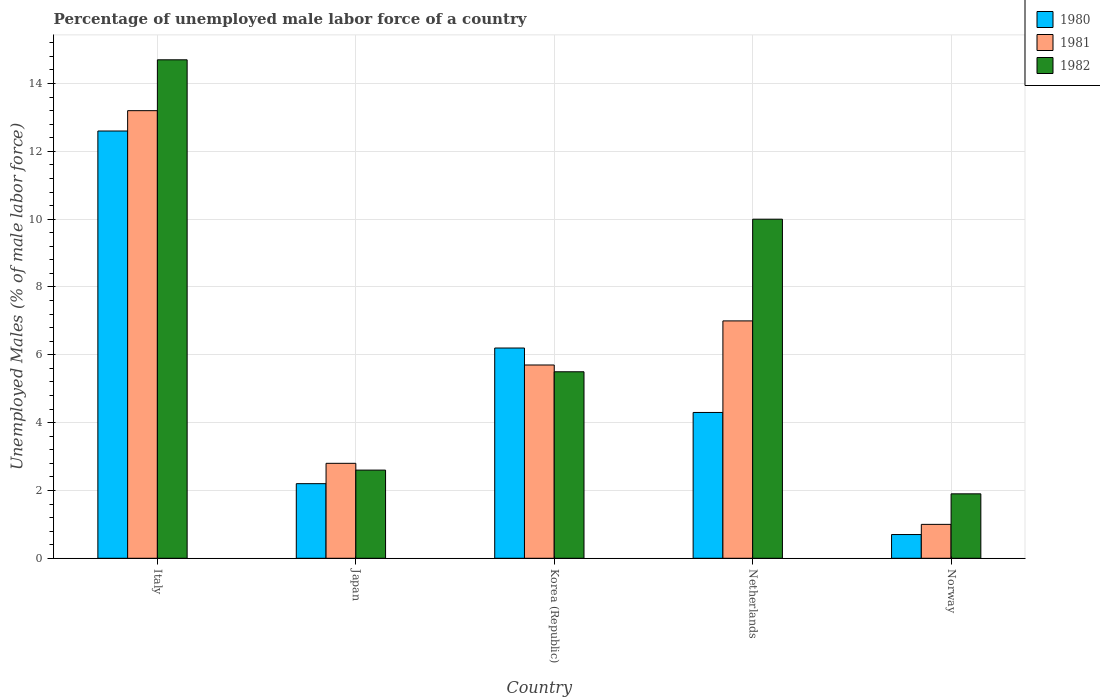How many different coloured bars are there?
Keep it short and to the point. 3. Are the number of bars per tick equal to the number of legend labels?
Provide a succinct answer. Yes. Are the number of bars on each tick of the X-axis equal?
Provide a succinct answer. Yes. How many bars are there on the 1st tick from the right?
Provide a short and direct response. 3. In how many cases, is the number of bars for a given country not equal to the number of legend labels?
Your answer should be very brief. 0. What is the percentage of unemployed male labor force in 1980 in Italy?
Provide a short and direct response. 12.6. Across all countries, what is the maximum percentage of unemployed male labor force in 1981?
Your answer should be compact. 13.2. Across all countries, what is the minimum percentage of unemployed male labor force in 1980?
Make the answer very short. 0.7. In which country was the percentage of unemployed male labor force in 1981 minimum?
Keep it short and to the point. Norway. What is the total percentage of unemployed male labor force in 1981 in the graph?
Your response must be concise. 29.7. What is the difference between the percentage of unemployed male labor force in 1981 in Italy and that in Japan?
Offer a terse response. 10.4. What is the difference between the percentage of unemployed male labor force in 1982 in Netherlands and the percentage of unemployed male labor force in 1981 in Korea (Republic)?
Give a very brief answer. 4.3. What is the average percentage of unemployed male labor force in 1980 per country?
Offer a very short reply. 5.2. What is the difference between the percentage of unemployed male labor force of/in 1982 and percentage of unemployed male labor force of/in 1980 in Korea (Republic)?
Make the answer very short. -0.7. In how many countries, is the percentage of unemployed male labor force in 1981 greater than 9.6 %?
Your response must be concise. 1. What is the ratio of the percentage of unemployed male labor force in 1981 in Japan to that in Norway?
Give a very brief answer. 2.8. Is the percentage of unemployed male labor force in 1980 in Korea (Republic) less than that in Norway?
Offer a very short reply. No. Is the difference between the percentage of unemployed male labor force in 1982 in Korea (Republic) and Netherlands greater than the difference between the percentage of unemployed male labor force in 1980 in Korea (Republic) and Netherlands?
Your answer should be compact. No. What is the difference between the highest and the lowest percentage of unemployed male labor force in 1980?
Give a very brief answer. 11.9. Is the sum of the percentage of unemployed male labor force in 1982 in Korea (Republic) and Norway greater than the maximum percentage of unemployed male labor force in 1980 across all countries?
Your response must be concise. No. What does the 2nd bar from the right in Japan represents?
Your answer should be compact. 1981. Are all the bars in the graph horizontal?
Your answer should be very brief. No. How many countries are there in the graph?
Your answer should be very brief. 5. Are the values on the major ticks of Y-axis written in scientific E-notation?
Keep it short and to the point. No. Does the graph contain any zero values?
Offer a very short reply. No. Does the graph contain grids?
Your answer should be compact. Yes. How are the legend labels stacked?
Your response must be concise. Vertical. What is the title of the graph?
Give a very brief answer. Percentage of unemployed male labor force of a country. What is the label or title of the X-axis?
Your response must be concise. Country. What is the label or title of the Y-axis?
Your answer should be compact. Unemployed Males (% of male labor force). What is the Unemployed Males (% of male labor force) of 1980 in Italy?
Provide a succinct answer. 12.6. What is the Unemployed Males (% of male labor force) of 1981 in Italy?
Your answer should be compact. 13.2. What is the Unemployed Males (% of male labor force) of 1982 in Italy?
Provide a short and direct response. 14.7. What is the Unemployed Males (% of male labor force) of 1980 in Japan?
Offer a terse response. 2.2. What is the Unemployed Males (% of male labor force) in 1981 in Japan?
Your response must be concise. 2.8. What is the Unemployed Males (% of male labor force) of 1982 in Japan?
Provide a short and direct response. 2.6. What is the Unemployed Males (% of male labor force) in 1980 in Korea (Republic)?
Offer a very short reply. 6.2. What is the Unemployed Males (% of male labor force) of 1981 in Korea (Republic)?
Offer a terse response. 5.7. What is the Unemployed Males (% of male labor force) of 1980 in Netherlands?
Keep it short and to the point. 4.3. What is the Unemployed Males (% of male labor force) of 1982 in Netherlands?
Give a very brief answer. 10. What is the Unemployed Males (% of male labor force) in 1980 in Norway?
Make the answer very short. 0.7. What is the Unemployed Males (% of male labor force) of 1981 in Norway?
Make the answer very short. 1. What is the Unemployed Males (% of male labor force) in 1982 in Norway?
Offer a very short reply. 1.9. Across all countries, what is the maximum Unemployed Males (% of male labor force) in 1980?
Offer a very short reply. 12.6. Across all countries, what is the maximum Unemployed Males (% of male labor force) in 1981?
Offer a terse response. 13.2. Across all countries, what is the maximum Unemployed Males (% of male labor force) of 1982?
Provide a short and direct response. 14.7. Across all countries, what is the minimum Unemployed Males (% of male labor force) of 1980?
Make the answer very short. 0.7. Across all countries, what is the minimum Unemployed Males (% of male labor force) of 1982?
Your answer should be compact. 1.9. What is the total Unemployed Males (% of male labor force) of 1980 in the graph?
Offer a terse response. 26. What is the total Unemployed Males (% of male labor force) in 1981 in the graph?
Make the answer very short. 29.7. What is the total Unemployed Males (% of male labor force) of 1982 in the graph?
Your answer should be very brief. 34.7. What is the difference between the Unemployed Males (% of male labor force) of 1981 in Italy and that in Japan?
Offer a terse response. 10.4. What is the difference between the Unemployed Males (% of male labor force) of 1981 in Italy and that in Korea (Republic)?
Provide a succinct answer. 7.5. What is the difference between the Unemployed Males (% of male labor force) of 1980 in Italy and that in Netherlands?
Provide a short and direct response. 8.3. What is the difference between the Unemployed Males (% of male labor force) of 1982 in Italy and that in Netherlands?
Keep it short and to the point. 4.7. What is the difference between the Unemployed Males (% of male labor force) of 1980 in Italy and that in Norway?
Your answer should be very brief. 11.9. What is the difference between the Unemployed Males (% of male labor force) in 1982 in Italy and that in Norway?
Provide a succinct answer. 12.8. What is the difference between the Unemployed Males (% of male labor force) of 1980 in Japan and that in Korea (Republic)?
Your response must be concise. -4. What is the difference between the Unemployed Males (% of male labor force) in 1981 in Japan and that in Korea (Republic)?
Make the answer very short. -2.9. What is the difference between the Unemployed Males (% of male labor force) of 1982 in Japan and that in Korea (Republic)?
Ensure brevity in your answer.  -2.9. What is the difference between the Unemployed Males (% of male labor force) of 1980 in Japan and that in Netherlands?
Your answer should be compact. -2.1. What is the difference between the Unemployed Males (% of male labor force) in 1980 in Japan and that in Norway?
Your answer should be very brief. 1.5. What is the difference between the Unemployed Males (% of male labor force) in 1982 in Japan and that in Norway?
Your answer should be compact. 0.7. What is the difference between the Unemployed Males (% of male labor force) of 1980 in Korea (Republic) and that in Netherlands?
Your answer should be very brief. 1.9. What is the difference between the Unemployed Males (% of male labor force) in 1981 in Korea (Republic) and that in Netherlands?
Keep it short and to the point. -1.3. What is the difference between the Unemployed Males (% of male labor force) in 1982 in Korea (Republic) and that in Netherlands?
Your answer should be very brief. -4.5. What is the difference between the Unemployed Males (% of male labor force) of 1982 in Korea (Republic) and that in Norway?
Give a very brief answer. 3.6. What is the difference between the Unemployed Males (% of male labor force) in 1980 in Netherlands and that in Norway?
Ensure brevity in your answer.  3.6. What is the difference between the Unemployed Males (% of male labor force) in 1981 in Netherlands and that in Norway?
Make the answer very short. 6. What is the difference between the Unemployed Males (% of male labor force) of 1980 in Italy and the Unemployed Males (% of male labor force) of 1982 in Japan?
Your answer should be compact. 10. What is the difference between the Unemployed Males (% of male labor force) in 1980 in Italy and the Unemployed Males (% of male labor force) in 1981 in Korea (Republic)?
Your answer should be compact. 6.9. What is the difference between the Unemployed Males (% of male labor force) in 1980 in Italy and the Unemployed Males (% of male labor force) in 1982 in Korea (Republic)?
Give a very brief answer. 7.1. What is the difference between the Unemployed Males (% of male labor force) in 1981 in Italy and the Unemployed Males (% of male labor force) in 1982 in Korea (Republic)?
Ensure brevity in your answer.  7.7. What is the difference between the Unemployed Males (% of male labor force) in 1980 in Italy and the Unemployed Males (% of male labor force) in 1981 in Netherlands?
Offer a terse response. 5.6. What is the difference between the Unemployed Males (% of male labor force) of 1981 in Italy and the Unemployed Males (% of male labor force) of 1982 in Norway?
Make the answer very short. 11.3. What is the difference between the Unemployed Males (% of male labor force) in 1980 in Japan and the Unemployed Males (% of male labor force) in 1981 in Korea (Republic)?
Make the answer very short. -3.5. What is the difference between the Unemployed Males (% of male labor force) in 1980 in Japan and the Unemployed Males (% of male labor force) in 1982 in Korea (Republic)?
Your answer should be compact. -3.3. What is the difference between the Unemployed Males (% of male labor force) of 1981 in Japan and the Unemployed Males (% of male labor force) of 1982 in Korea (Republic)?
Offer a very short reply. -2.7. What is the difference between the Unemployed Males (% of male labor force) in 1980 in Japan and the Unemployed Males (% of male labor force) in 1981 in Norway?
Ensure brevity in your answer.  1.2. What is the difference between the Unemployed Males (% of male labor force) in 1980 in Korea (Republic) and the Unemployed Males (% of male labor force) in 1981 in Netherlands?
Give a very brief answer. -0.8. What is the difference between the Unemployed Males (% of male labor force) of 1980 in Korea (Republic) and the Unemployed Males (% of male labor force) of 1982 in Netherlands?
Your response must be concise. -3.8. What is the difference between the Unemployed Males (% of male labor force) of 1980 in Korea (Republic) and the Unemployed Males (% of male labor force) of 1981 in Norway?
Keep it short and to the point. 5.2. What is the difference between the Unemployed Males (% of male labor force) of 1981 in Korea (Republic) and the Unemployed Males (% of male labor force) of 1982 in Norway?
Offer a terse response. 3.8. What is the difference between the Unemployed Males (% of male labor force) of 1980 in Netherlands and the Unemployed Males (% of male labor force) of 1982 in Norway?
Provide a short and direct response. 2.4. What is the difference between the Unemployed Males (% of male labor force) of 1981 in Netherlands and the Unemployed Males (% of male labor force) of 1982 in Norway?
Ensure brevity in your answer.  5.1. What is the average Unemployed Males (% of male labor force) of 1981 per country?
Provide a short and direct response. 5.94. What is the average Unemployed Males (% of male labor force) in 1982 per country?
Keep it short and to the point. 6.94. What is the difference between the Unemployed Males (% of male labor force) in 1980 and Unemployed Males (% of male labor force) in 1981 in Japan?
Offer a very short reply. -0.6. What is the difference between the Unemployed Males (% of male labor force) in 1980 and Unemployed Males (% of male labor force) in 1982 in Japan?
Make the answer very short. -0.4. What is the difference between the Unemployed Males (% of male labor force) of 1980 and Unemployed Males (% of male labor force) of 1981 in Korea (Republic)?
Your answer should be very brief. 0.5. What is the difference between the Unemployed Males (% of male labor force) in 1980 and Unemployed Males (% of male labor force) in 1982 in Korea (Republic)?
Offer a very short reply. 0.7. What is the difference between the Unemployed Males (% of male labor force) of 1980 and Unemployed Males (% of male labor force) of 1981 in Netherlands?
Your response must be concise. -2.7. What is the difference between the Unemployed Males (% of male labor force) in 1980 and Unemployed Males (% of male labor force) in 1982 in Netherlands?
Keep it short and to the point. -5.7. What is the difference between the Unemployed Males (% of male labor force) of 1981 and Unemployed Males (% of male labor force) of 1982 in Netherlands?
Offer a very short reply. -3. What is the difference between the Unemployed Males (% of male labor force) of 1980 and Unemployed Males (% of male labor force) of 1981 in Norway?
Make the answer very short. -0.3. What is the ratio of the Unemployed Males (% of male labor force) of 1980 in Italy to that in Japan?
Offer a terse response. 5.73. What is the ratio of the Unemployed Males (% of male labor force) of 1981 in Italy to that in Japan?
Provide a succinct answer. 4.71. What is the ratio of the Unemployed Males (% of male labor force) in 1982 in Italy to that in Japan?
Make the answer very short. 5.65. What is the ratio of the Unemployed Males (% of male labor force) in 1980 in Italy to that in Korea (Republic)?
Offer a very short reply. 2.03. What is the ratio of the Unemployed Males (% of male labor force) of 1981 in Italy to that in Korea (Republic)?
Ensure brevity in your answer.  2.32. What is the ratio of the Unemployed Males (% of male labor force) in 1982 in Italy to that in Korea (Republic)?
Your answer should be very brief. 2.67. What is the ratio of the Unemployed Males (% of male labor force) in 1980 in Italy to that in Netherlands?
Your answer should be very brief. 2.93. What is the ratio of the Unemployed Males (% of male labor force) of 1981 in Italy to that in Netherlands?
Offer a terse response. 1.89. What is the ratio of the Unemployed Males (% of male labor force) in 1982 in Italy to that in Netherlands?
Make the answer very short. 1.47. What is the ratio of the Unemployed Males (% of male labor force) in 1982 in Italy to that in Norway?
Give a very brief answer. 7.74. What is the ratio of the Unemployed Males (% of male labor force) in 1980 in Japan to that in Korea (Republic)?
Your answer should be very brief. 0.35. What is the ratio of the Unemployed Males (% of male labor force) in 1981 in Japan to that in Korea (Republic)?
Provide a short and direct response. 0.49. What is the ratio of the Unemployed Males (% of male labor force) of 1982 in Japan to that in Korea (Republic)?
Your answer should be very brief. 0.47. What is the ratio of the Unemployed Males (% of male labor force) of 1980 in Japan to that in Netherlands?
Provide a short and direct response. 0.51. What is the ratio of the Unemployed Males (% of male labor force) in 1981 in Japan to that in Netherlands?
Your answer should be very brief. 0.4. What is the ratio of the Unemployed Males (% of male labor force) of 1982 in Japan to that in Netherlands?
Your answer should be very brief. 0.26. What is the ratio of the Unemployed Males (% of male labor force) of 1980 in Japan to that in Norway?
Offer a terse response. 3.14. What is the ratio of the Unemployed Males (% of male labor force) in 1981 in Japan to that in Norway?
Your response must be concise. 2.8. What is the ratio of the Unemployed Males (% of male labor force) in 1982 in Japan to that in Norway?
Give a very brief answer. 1.37. What is the ratio of the Unemployed Males (% of male labor force) of 1980 in Korea (Republic) to that in Netherlands?
Keep it short and to the point. 1.44. What is the ratio of the Unemployed Males (% of male labor force) of 1981 in Korea (Republic) to that in Netherlands?
Offer a terse response. 0.81. What is the ratio of the Unemployed Males (% of male labor force) of 1982 in Korea (Republic) to that in Netherlands?
Ensure brevity in your answer.  0.55. What is the ratio of the Unemployed Males (% of male labor force) of 1980 in Korea (Republic) to that in Norway?
Make the answer very short. 8.86. What is the ratio of the Unemployed Males (% of male labor force) in 1982 in Korea (Republic) to that in Norway?
Give a very brief answer. 2.89. What is the ratio of the Unemployed Males (% of male labor force) in 1980 in Netherlands to that in Norway?
Offer a terse response. 6.14. What is the ratio of the Unemployed Males (% of male labor force) in 1981 in Netherlands to that in Norway?
Ensure brevity in your answer.  7. What is the ratio of the Unemployed Males (% of male labor force) of 1982 in Netherlands to that in Norway?
Give a very brief answer. 5.26. What is the difference between the highest and the second highest Unemployed Males (% of male labor force) in 1980?
Your response must be concise. 6.4. What is the difference between the highest and the second highest Unemployed Males (% of male labor force) of 1982?
Provide a short and direct response. 4.7. What is the difference between the highest and the lowest Unemployed Males (% of male labor force) of 1980?
Give a very brief answer. 11.9. What is the difference between the highest and the lowest Unemployed Males (% of male labor force) of 1981?
Your response must be concise. 12.2. What is the difference between the highest and the lowest Unemployed Males (% of male labor force) in 1982?
Ensure brevity in your answer.  12.8. 